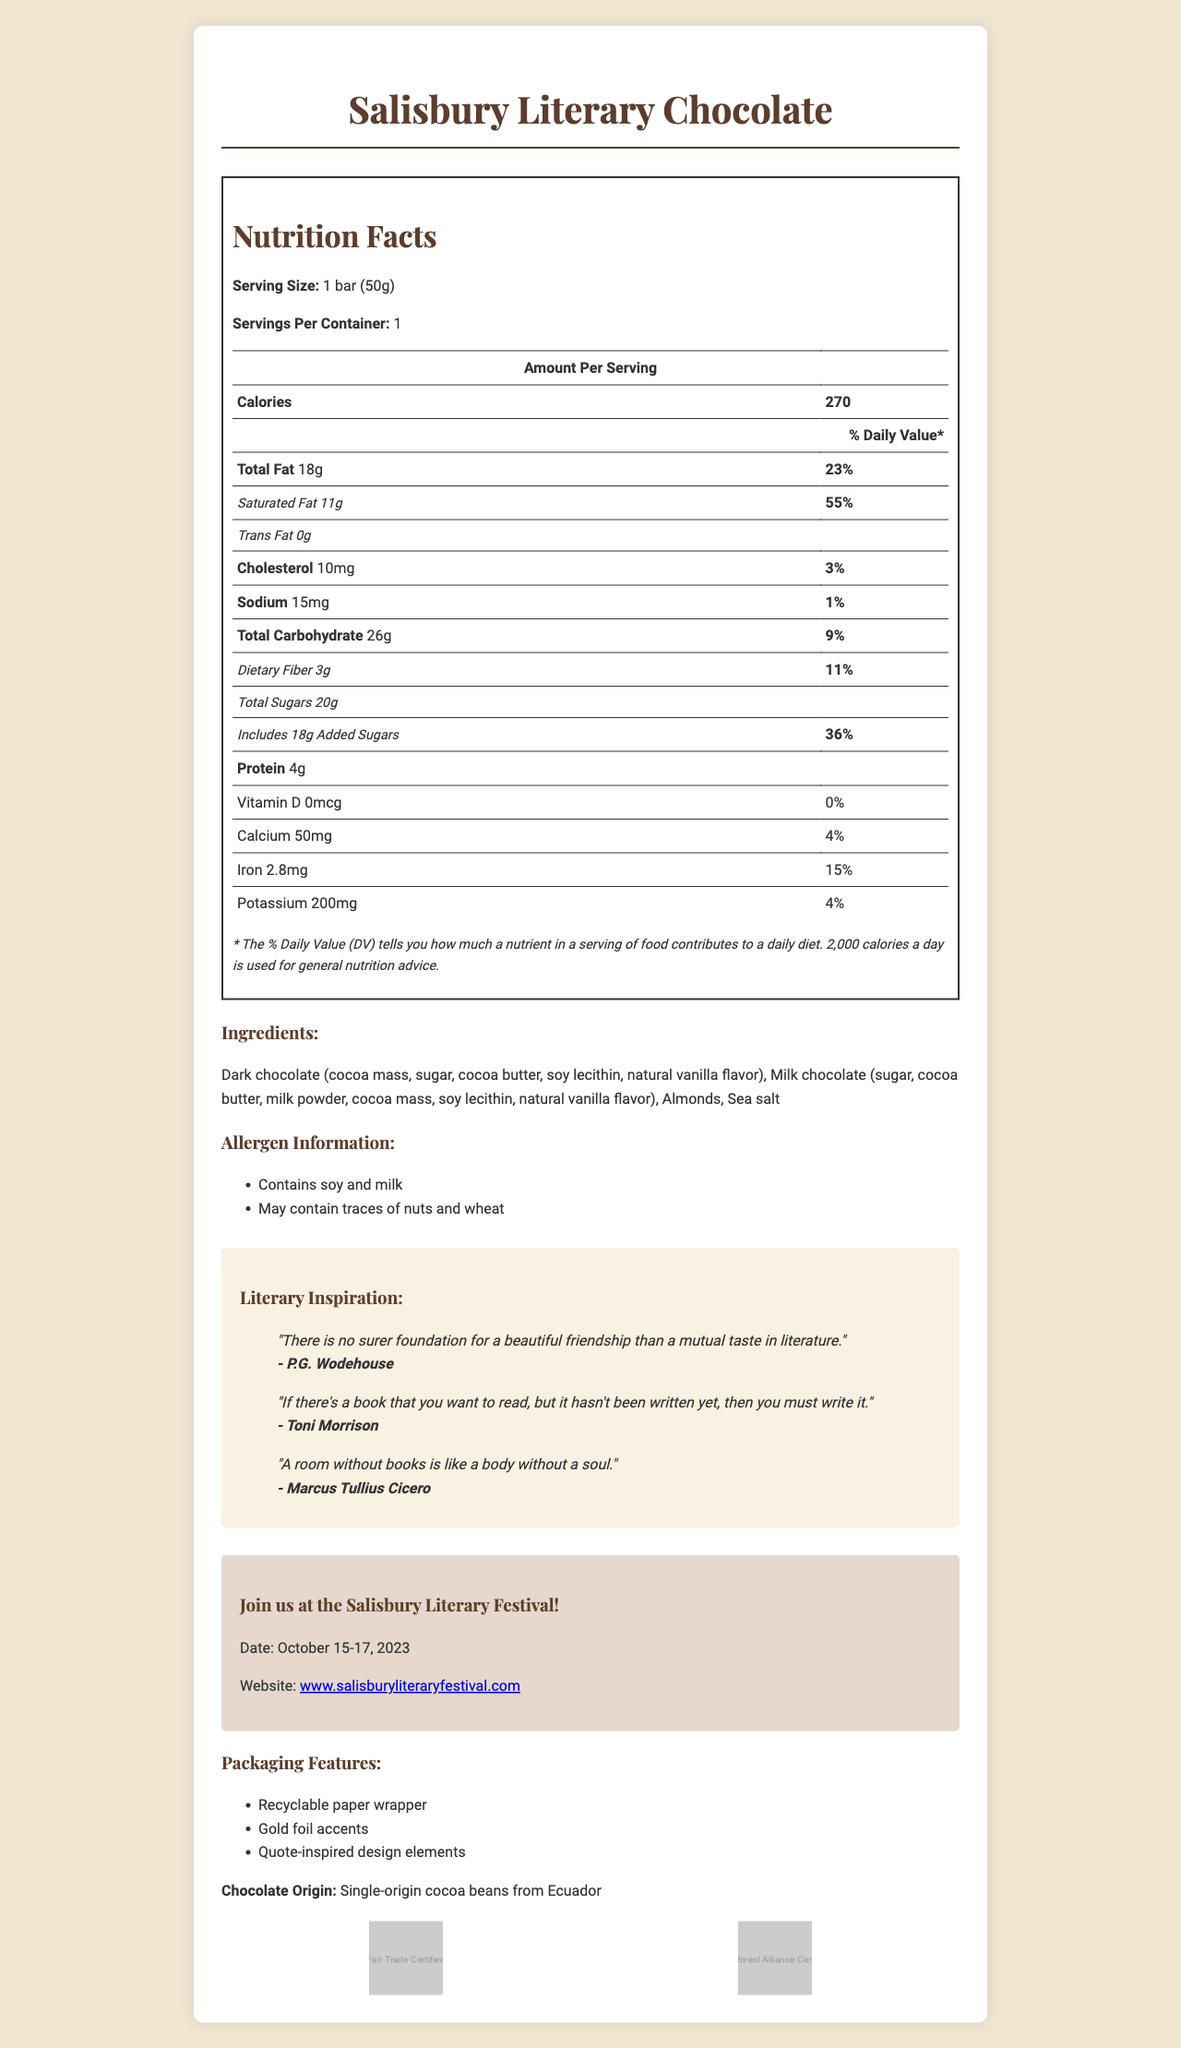What is the calories amount per bar? The Nutrition Facts section at the top of the document indicates that the calories amount per serving (which is one bar) is 270.
Answer: 270 What is the serving size of the Salisbury Literary Chocolate bar? The document clearly mentions the serving size as 1 bar (50g) right under the product name and nutrition facts.
Answer: 1 bar (50g) How much saturated fat is in one serving of the chocolate? Under the Total Fat section, it notes that the chocolate contains 11g of saturated fat per serving.
Answer: 11g What allergens are present in the Salisbury Literary Chocolate? The Allergen Information section lists soy and milk as allergens and notes that it may contain traces of nuts and wheat.
Answer: Contains soy and milk; May contain traces of nuts and wheat What is the total carbohydrate content per serving? The Nutrition Facts section provides the total carbohydrate content as 26g per serving.
Answer: 26g Which of the following authors' quotes are included on the packaging? A. J.K. Rowling B. P.G. Wodehouse C. Jane Austen D. George Orwell The document features a quote from P.G. Wodehouse in the Literary Inspiration section, along with quotes from Toni Morrison and Marcus Tullius Cicero, but none from J.K. Rowling, Jane Austen, or George Orwell.
Answer: B. P.G. Wodehouse How much protein is contained in one serving of the Salisbury Literary Chocolate bar? The Nutrition Facts section lists 4g of protein in each serving of the chocolate bar.
Answer: 4g What is the amount of added sugars in the Salisbury Literary Chocolate bar? The total sugars section includes a note saying that the bar includes 18g of added sugars.
Answer: 18g Is the Salisbury Literary Chocolate bar Fair Trade Certified? The Certifications section shows a Fair Trade Certification logo, indicating the chocolate is Fair Trade Certified.
Answer: Yes Describe the sustainability and ethical sourcing aspects of the Salisbury Literary Chocolate. The document highlights that the chocolate comes from single-origin cocoa beans from Ecuador, and lists Fair Trade Certification and Rainforest Alliance Certification. It also mentions that the packaging is recyclable.
Answer: The chocolate is made from single-origin cocoa beans from Ecuador and is both Fair Trade Certified and Rainforest Alliance Certified. The packaging is recyclable with gold foil accents and includes quote-inspired design elements. When will the Salisbury Literary Festival take place? The Festival Information section provides the date of the Salisbury Literary Festival as October 15-17, 2023.
Answer: October 15-17, 2023 Can we determine the specific vendor or retailer selling the Salisbury Literary Chocolate from the document? The document does not provide information about the vendors or retailers selling the Salisbury Literary Chocolate.
Answer: Cannot be determined What is the packaging of the chocolate wrapper made of? The Packaging Features section states that the wrapper is made of recyclable paper.
Answer: Recyclable paper Which website is listed for further details about the Salisbury Literary Festival? The Festival Information section provides the website www.salisburyliteraryfestival.com for more information.
Answer: www.salisburyliteraryfestival.com How many servings does one container of Salisbury Literary Chocolate have? The document specifies that there is one serving per container under the Nutrition Facts section.
Answer: 1 